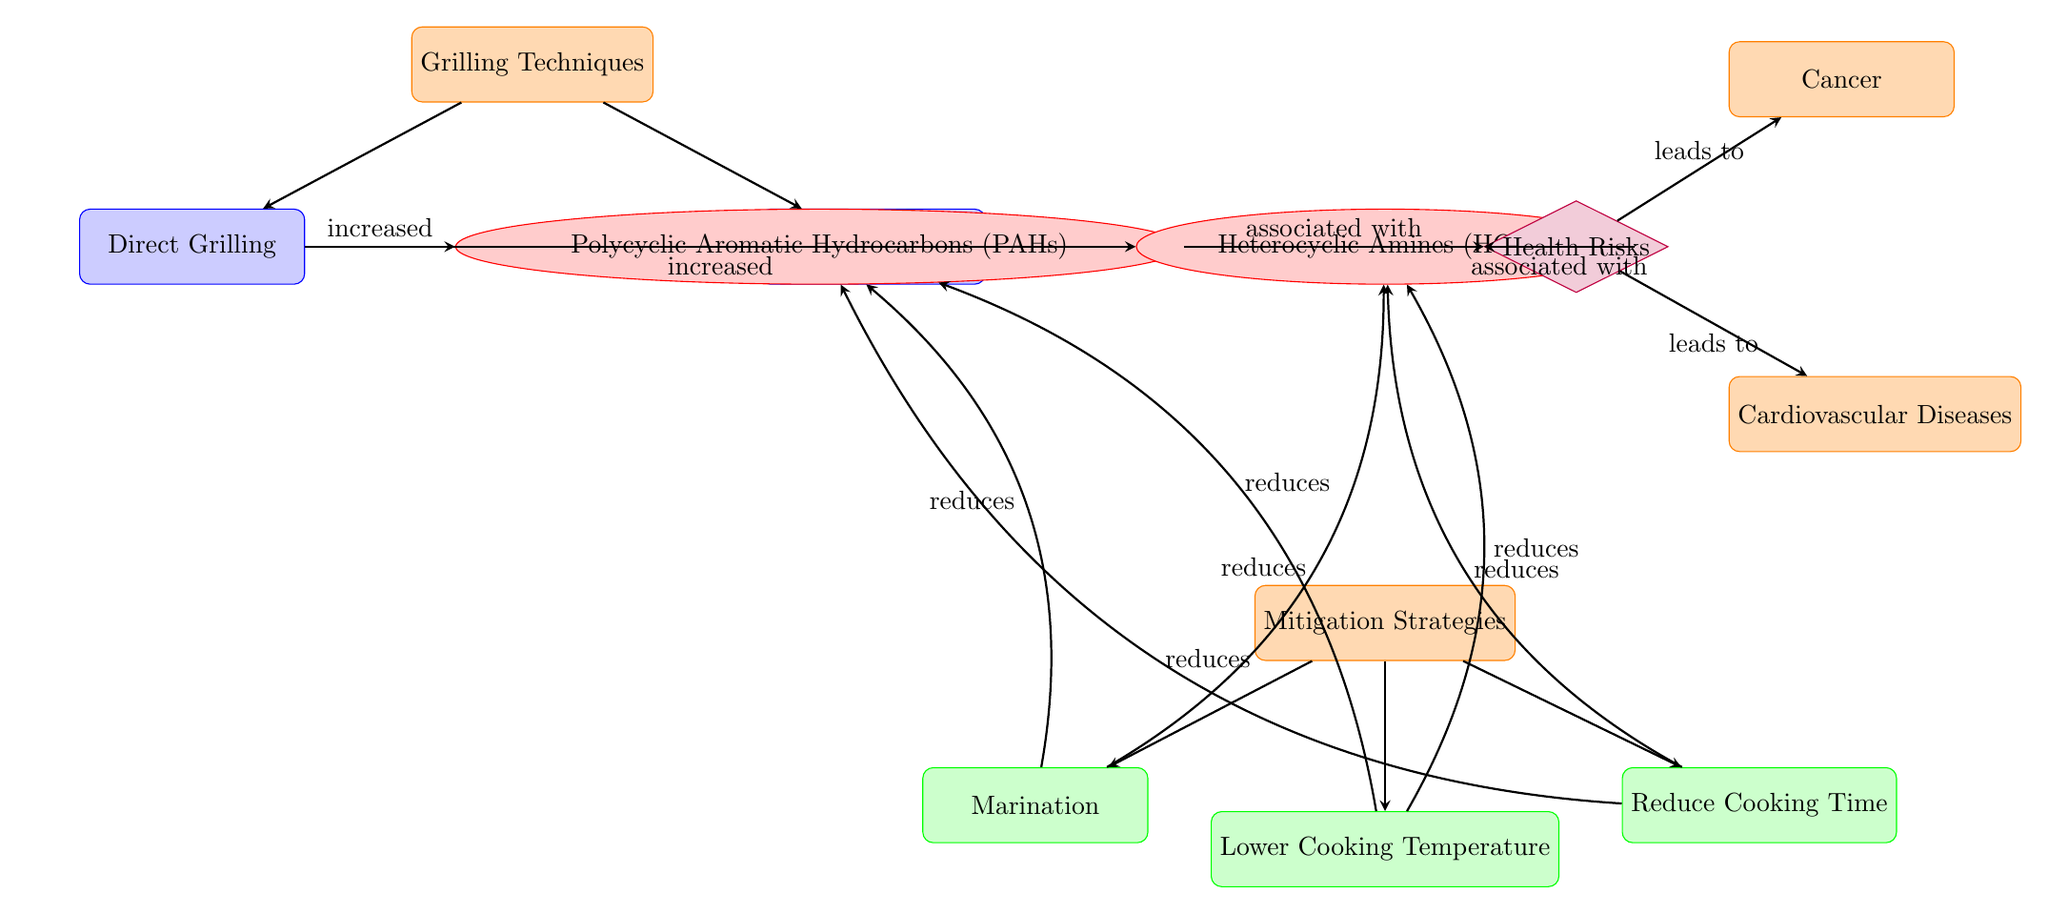What's the main topic of the diagram? The title of the diagram indicates that it focuses on the formation of harmful compounds (PAHs and HCAs) during different grilling techniques and their health risks. This primary focus is determined by reviewing the overarching title of the diagram.
Answer: Formation of Harmful Compounds (PAHs and HCAs) How many grilling techniques are mentioned in the diagram? The diagram outlines two grilling techniques: Direct Grilling and Indirect Grilling, which can be counted by examining the section titled "Grilling Techniques" where these two nodes are clearly listed.
Answer: 2 What compound is associated with Direct Grilling? According to the diagram, Direct Grilling is linked to the formation of Polycyclic Aromatic Hydrocarbons (PAHs), which is indicated by the direct connection from the Direct Grilling node to the PAHs node.
Answer: Polycyclic Aromatic Hydrocarbons (PAHs) What health risk is indicated as a consequence of both PAHs and HCAs? The diagram shows Health Risks due to connections coming from both the PAHs and HCAs nodes, suggesting that both are associated with general health risks; this is detailed in the middle part of the diagram.
Answer: Health Risks Which mitigation strategy is directly linked to reducing both PAHs and HCAs? The diagram provides an overall section for Mitigation Strategies where all three listed strategies (Marination, Lower Cooking Temperature, and Reduce Cooking Time) directly link to reductions in both PAHs and HCAs, showing that these strategies are all effective in mitigation efforts against these harmful compounds.
Answer: All three strategies What are the two diseases that are specifically connected to Health Risks in the diagram? The diagram indicates that both Cancer and Cardiovascular Diseases are the outcomes leading from Health Risks, illustrated through the lower section links descending from the Health Risks node to these two disease nodes.
Answer: Cancer and Cardiovascular Diseases What effect does marination have according to the diagram? The diagram specifies that marination reduces both PAHs and HCAs based on the arrows leading from the Mitigation Strategies node, showing a bidirectional relationship towards both harmful compounds.
Answer: Reduces How does Indirect Grilling differ in compound formation compared to Direct Grilling? The diagram illustrates that Indirect Grilling leads to Heterocyclic Amines (HCAs) which are different from PAHs formed through Direct Grilling. This distinction is indicated by the specific branching from each grilling technique to its corresponding harmful compound.
Answer: Heterocyclic Amines (HCAs) 